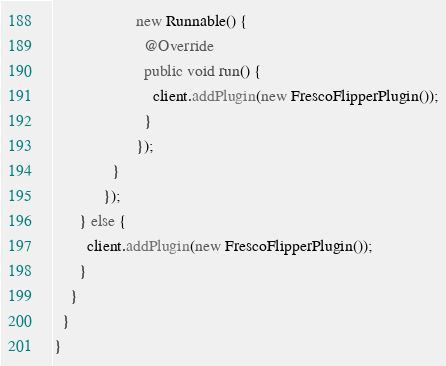<code> <loc_0><loc_0><loc_500><loc_500><_Java_>                    new Runnable() {
                      @Override
                      public void run() {
                        client.addPlugin(new FrescoFlipperPlugin());
                      }
                    });
              }
            });
      } else {
        client.addPlugin(new FrescoFlipperPlugin());
      }
    }
  }
}
</code> 